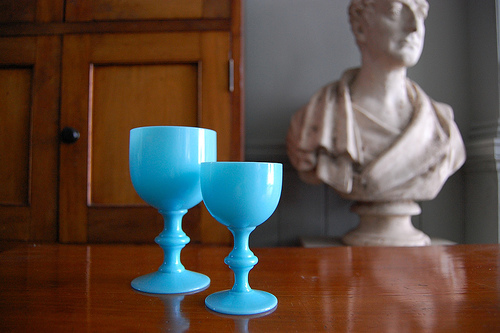<image>
Is the statue behind the table? Yes. From this viewpoint, the statue is positioned behind the table, with the table partially or fully occluding the statue. Is there a glass on the table? Yes. Looking at the image, I can see the glass is positioned on top of the table, with the table providing support. 